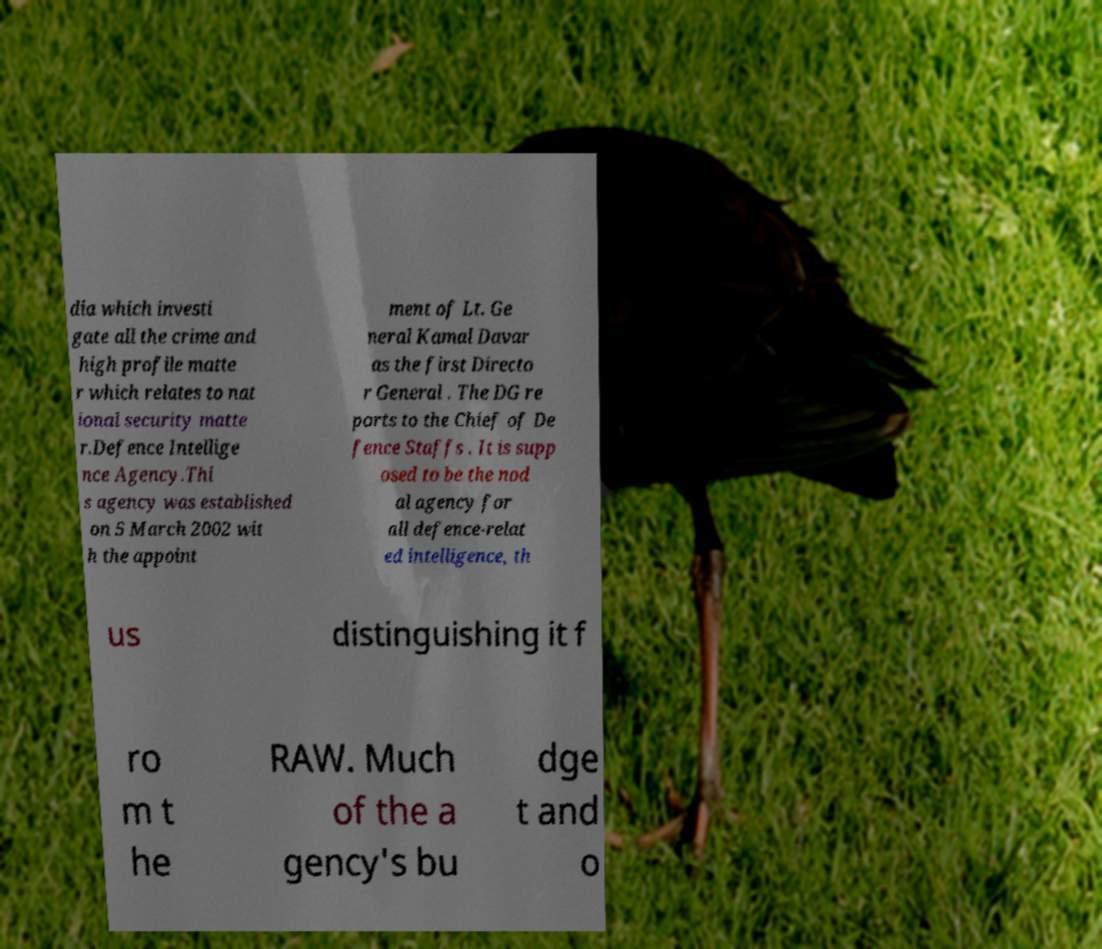There's text embedded in this image that I need extracted. Can you transcribe it verbatim? dia which investi gate all the crime and high profile matte r which relates to nat ional security matte r.Defence Intellige nce Agency.Thi s agency was established on 5 March 2002 wit h the appoint ment of Lt. Ge neral Kamal Davar as the first Directo r General . The DG re ports to the Chief of De fence Staffs . It is supp osed to be the nod al agency for all defence-relat ed intelligence, th us distinguishing it f ro m t he RAW. Much of the a gency's bu dge t and o 